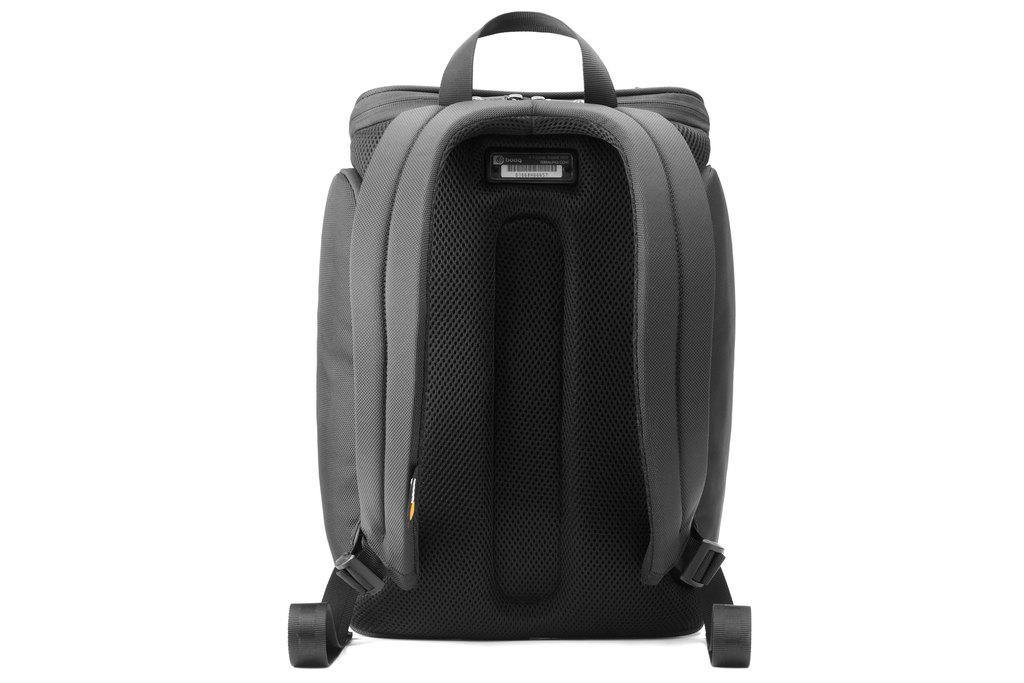What object can be seen in the image? There is a bag in the image. Can you describe the appearance of the bag? The bag is grey and black in color. How many ants are crawling on the bag in the image? There are no ants present in the image; it only shows a bag with a grey and black color scheme. 